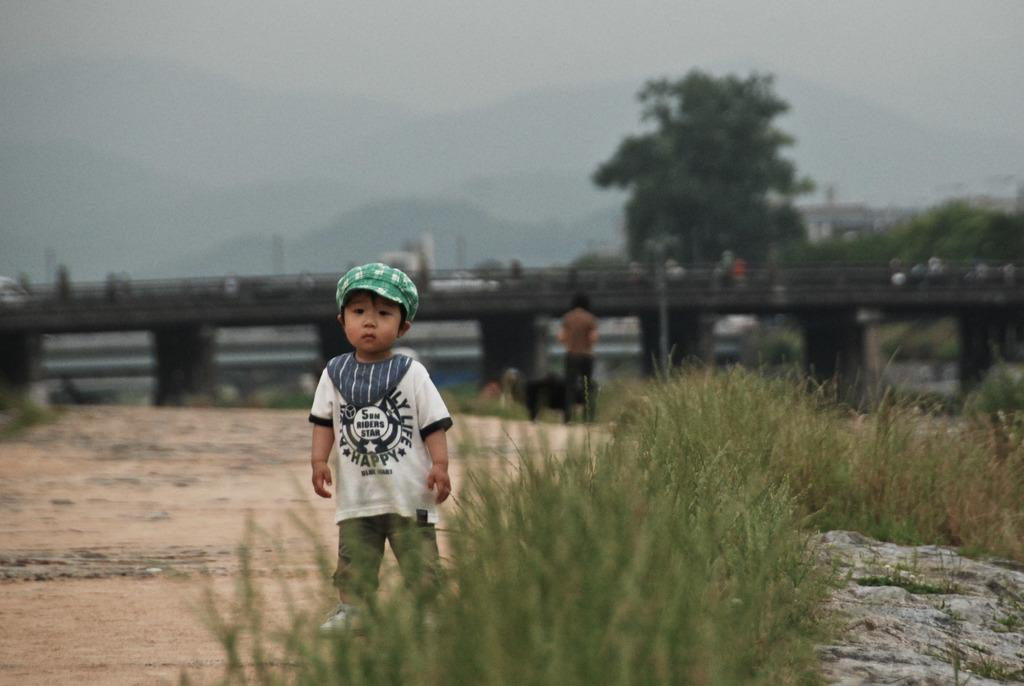What is the main subject of the image? The main subject of the image is a kid standing on the ground. What is the kid wearing on their head? The kid is wearing a cap. What type of vegetation can be seen in the image? There are plants visible in the image. What can be seen in the background of the image? There is a bridge, people, a tree, and the sky visible in the background of the image. What type of soda is the kid holding in the image? There is no soda present in the image; the kid is not holding any beverage. What type of work does the secretary do in the image? There is no secretary present in the image. 